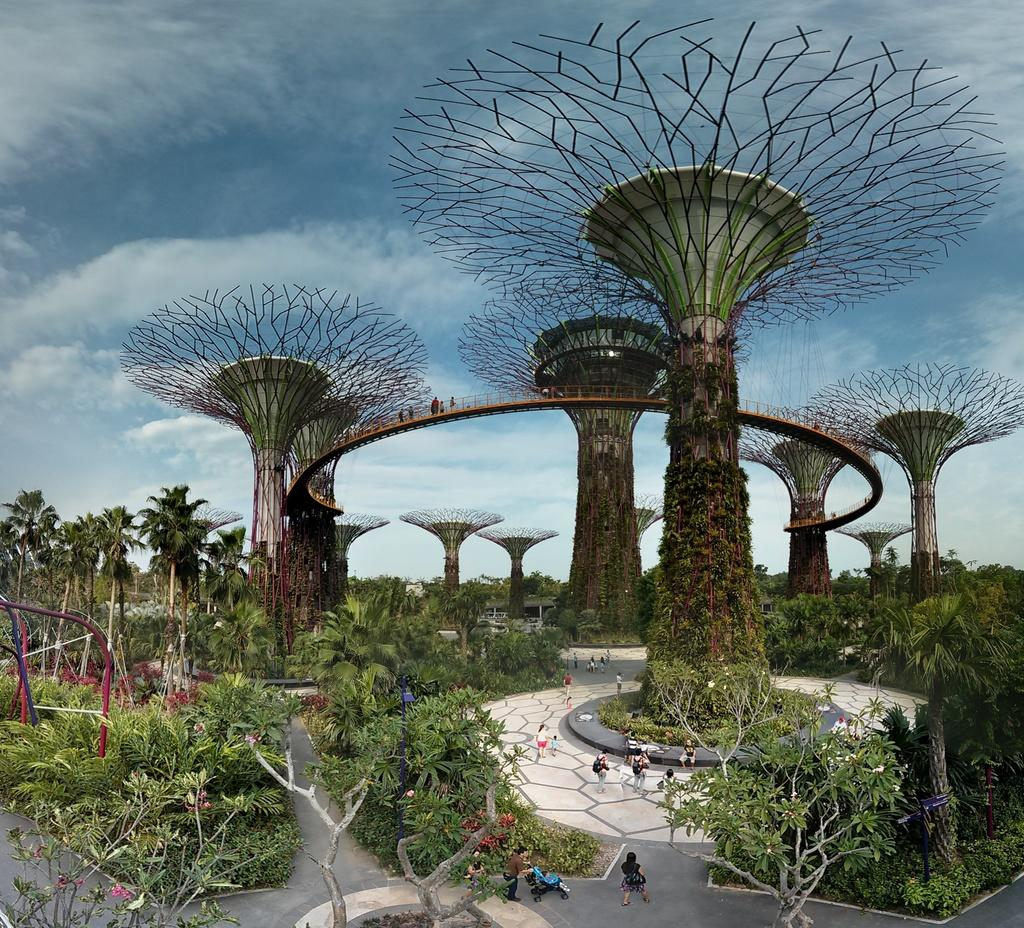What structures are located in the center of the image? There are pillars in the center of the image. What type of vegetation is present in the image? There are trees in the image. Who or what can be seen at the bottom of the image? People are visible at the bottom of the image. What is visible at the top of the image? The sky is visible at the top of the image. Where is the throne located in the image? There is no throne present in the image. Can you describe the blowing wind in the image? There is no mention of wind or blowing in the image. 